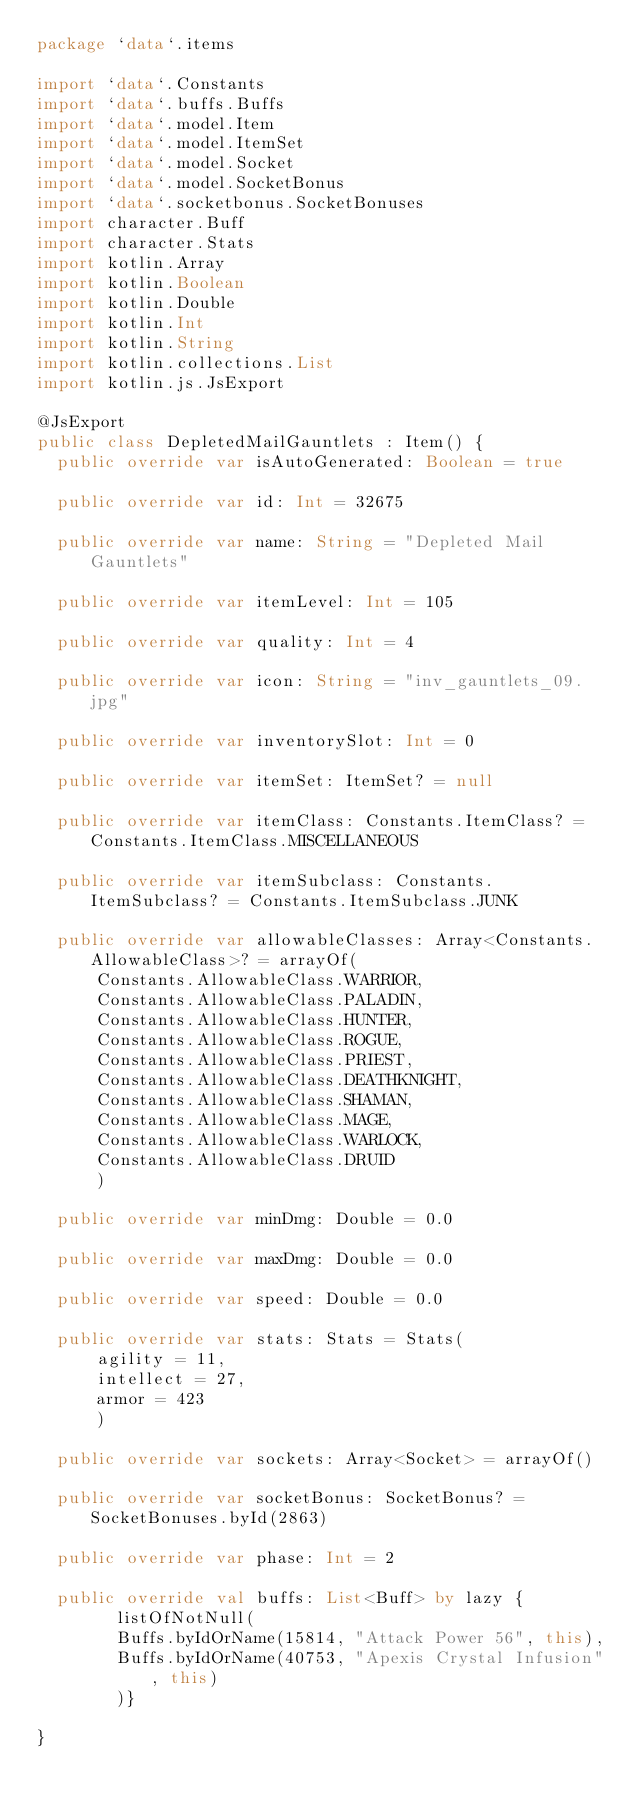Convert code to text. <code><loc_0><loc_0><loc_500><loc_500><_Kotlin_>package `data`.items

import `data`.Constants
import `data`.buffs.Buffs
import `data`.model.Item
import `data`.model.ItemSet
import `data`.model.Socket
import `data`.model.SocketBonus
import `data`.socketbonus.SocketBonuses
import character.Buff
import character.Stats
import kotlin.Array
import kotlin.Boolean
import kotlin.Double
import kotlin.Int
import kotlin.String
import kotlin.collections.List
import kotlin.js.JsExport

@JsExport
public class DepletedMailGauntlets : Item() {
  public override var isAutoGenerated: Boolean = true

  public override var id: Int = 32675

  public override var name: String = "Depleted Mail Gauntlets"

  public override var itemLevel: Int = 105

  public override var quality: Int = 4

  public override var icon: String = "inv_gauntlets_09.jpg"

  public override var inventorySlot: Int = 0

  public override var itemSet: ItemSet? = null

  public override var itemClass: Constants.ItemClass? = Constants.ItemClass.MISCELLANEOUS

  public override var itemSubclass: Constants.ItemSubclass? = Constants.ItemSubclass.JUNK

  public override var allowableClasses: Array<Constants.AllowableClass>? = arrayOf(
      Constants.AllowableClass.WARRIOR,
      Constants.AllowableClass.PALADIN,
      Constants.AllowableClass.HUNTER,
      Constants.AllowableClass.ROGUE,
      Constants.AllowableClass.PRIEST,
      Constants.AllowableClass.DEATHKNIGHT,
      Constants.AllowableClass.SHAMAN,
      Constants.AllowableClass.MAGE,
      Constants.AllowableClass.WARLOCK,
      Constants.AllowableClass.DRUID
      )

  public override var minDmg: Double = 0.0

  public override var maxDmg: Double = 0.0

  public override var speed: Double = 0.0

  public override var stats: Stats = Stats(
      agility = 11,
      intellect = 27,
      armor = 423
      )

  public override var sockets: Array<Socket> = arrayOf()

  public override var socketBonus: SocketBonus? = SocketBonuses.byId(2863)

  public override var phase: Int = 2

  public override val buffs: List<Buff> by lazy {
        listOfNotNull(
        Buffs.byIdOrName(15814, "Attack Power 56", this),
        Buffs.byIdOrName(40753, "Apexis Crystal Infusion", this)
        )}

}
</code> 